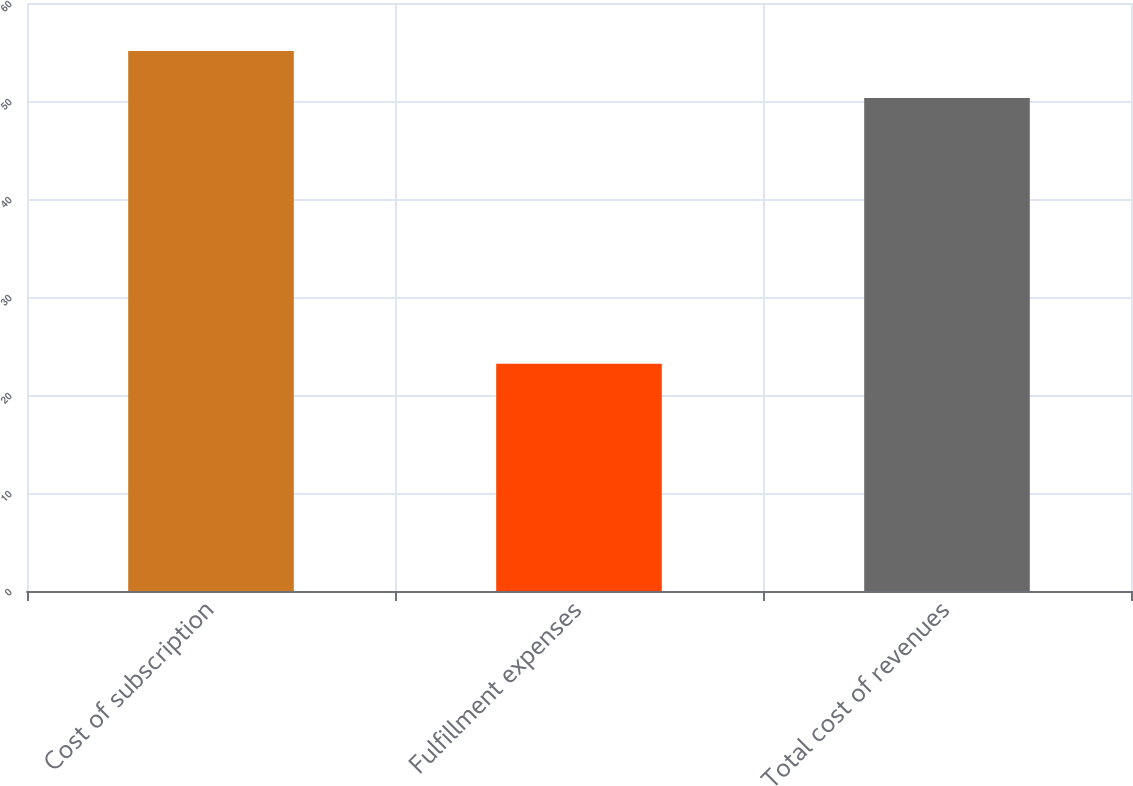<chart> <loc_0><loc_0><loc_500><loc_500><bar_chart><fcel>Cost of subscription<fcel>Fulfillment expenses<fcel>Total cost of revenues<nl><fcel>55.1<fcel>23.2<fcel>50.3<nl></chart> 